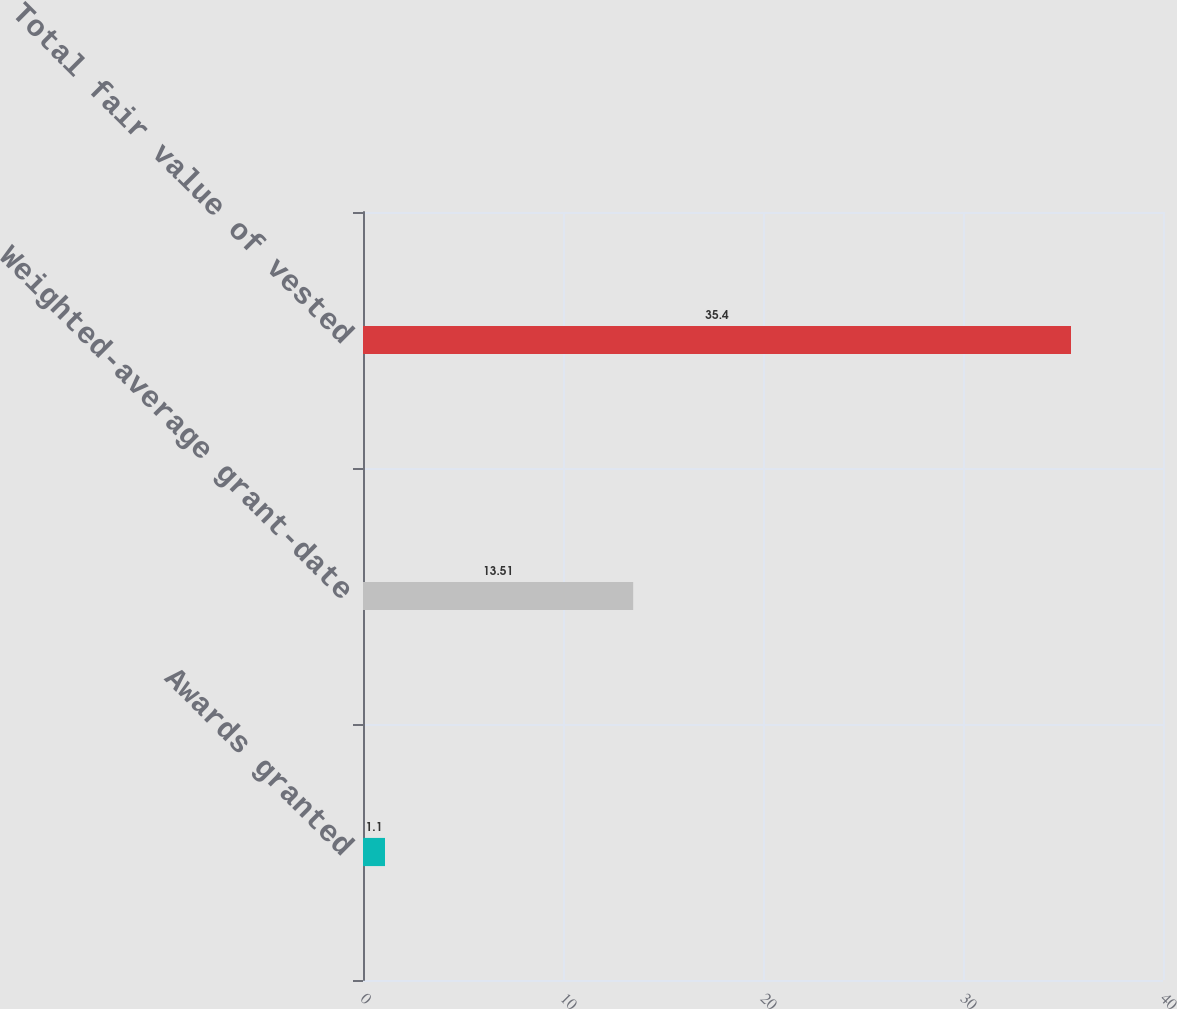Convert chart to OTSL. <chart><loc_0><loc_0><loc_500><loc_500><bar_chart><fcel>Awards granted<fcel>Weighted-average grant-date<fcel>Total fair value of vested<nl><fcel>1.1<fcel>13.51<fcel>35.4<nl></chart> 